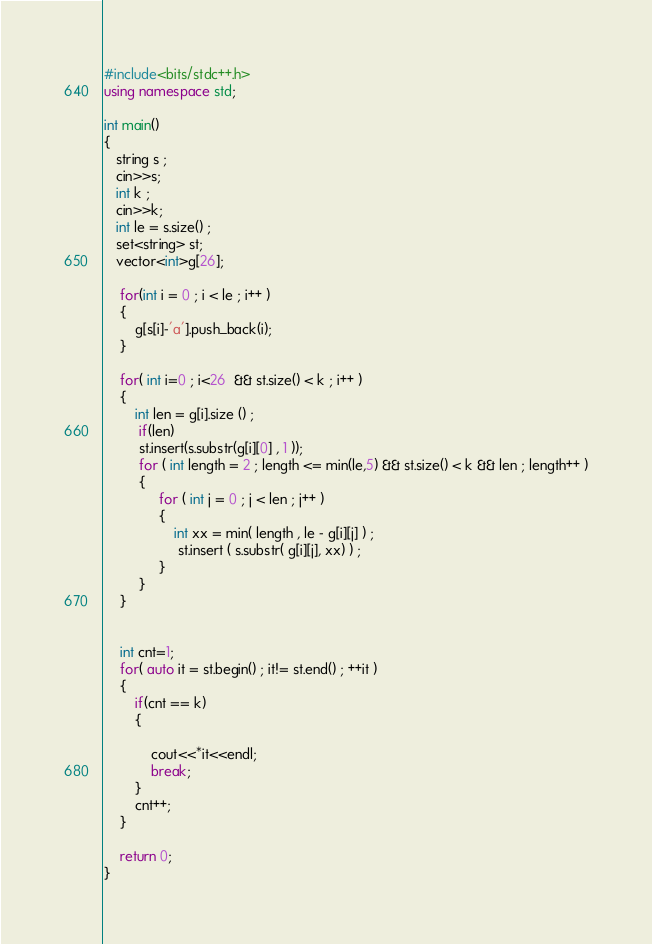<code> <loc_0><loc_0><loc_500><loc_500><_C++_>#include<bits/stdc++.h>
using namespace std;

int main()
{
   string s ;
   cin>>s;
   int k ;
   cin>>k;
   int le = s.size() ;
   set<string> st;
   vector<int>g[26];
    
    for(int i = 0 ; i < le ; i++ )
    {
        g[s[i]-'a'].push_back(i);
    }
    
    for( int i=0 ; i<26  && st.size() < k ; i++ )
    {
        int len = g[i].size () ;
         if(len) 
         st.insert(s.substr(g[i][0] , 1 ));
         for ( int length = 2 ; length <= min(le,5) && st.size() < k && len ; length++ )
         {
              for ( int j = 0 ; j < len ; j++ )
              {
                  int xx = min( length , le - g[i][j] ) ;
                   st.insert ( s.substr( g[i][j], xx) ) ;  
              }
         }
    }
        
    
    int cnt=1;
    for( auto it = st.begin() ; it!= st.end() ; ++it )
    {
        if(cnt == k)
        {
            
            cout<<*it<<endl;
            break;
        }
        cnt++;
    }
    
    return 0;
}</code> 